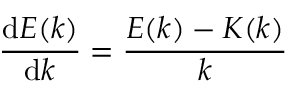Convert formula to latex. <formula><loc_0><loc_0><loc_500><loc_500>{ \frac { d E ( k ) } { d k } } = { \frac { E ( k ) - K ( k ) } { k } }</formula> 